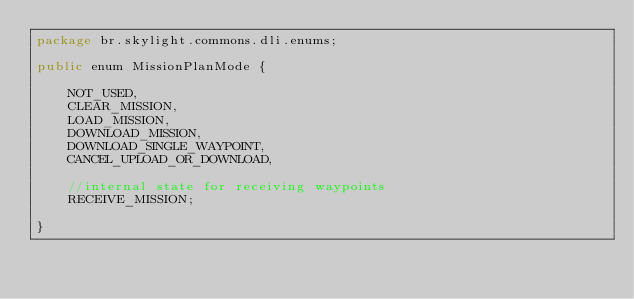Convert code to text. <code><loc_0><loc_0><loc_500><loc_500><_Java_>package br.skylight.commons.dli.enums;

public enum MissionPlanMode {

	NOT_USED,
	CLEAR_MISSION,
	LOAD_MISSION,
	DOWNLOAD_MISSION,
	DOWNLOAD_SINGLE_WAYPOINT,
	CANCEL_UPLOAD_OR_DOWNLOAD,
	
	//internal state for receiving waypoints
	RECEIVE_MISSION;
	
}
</code> 